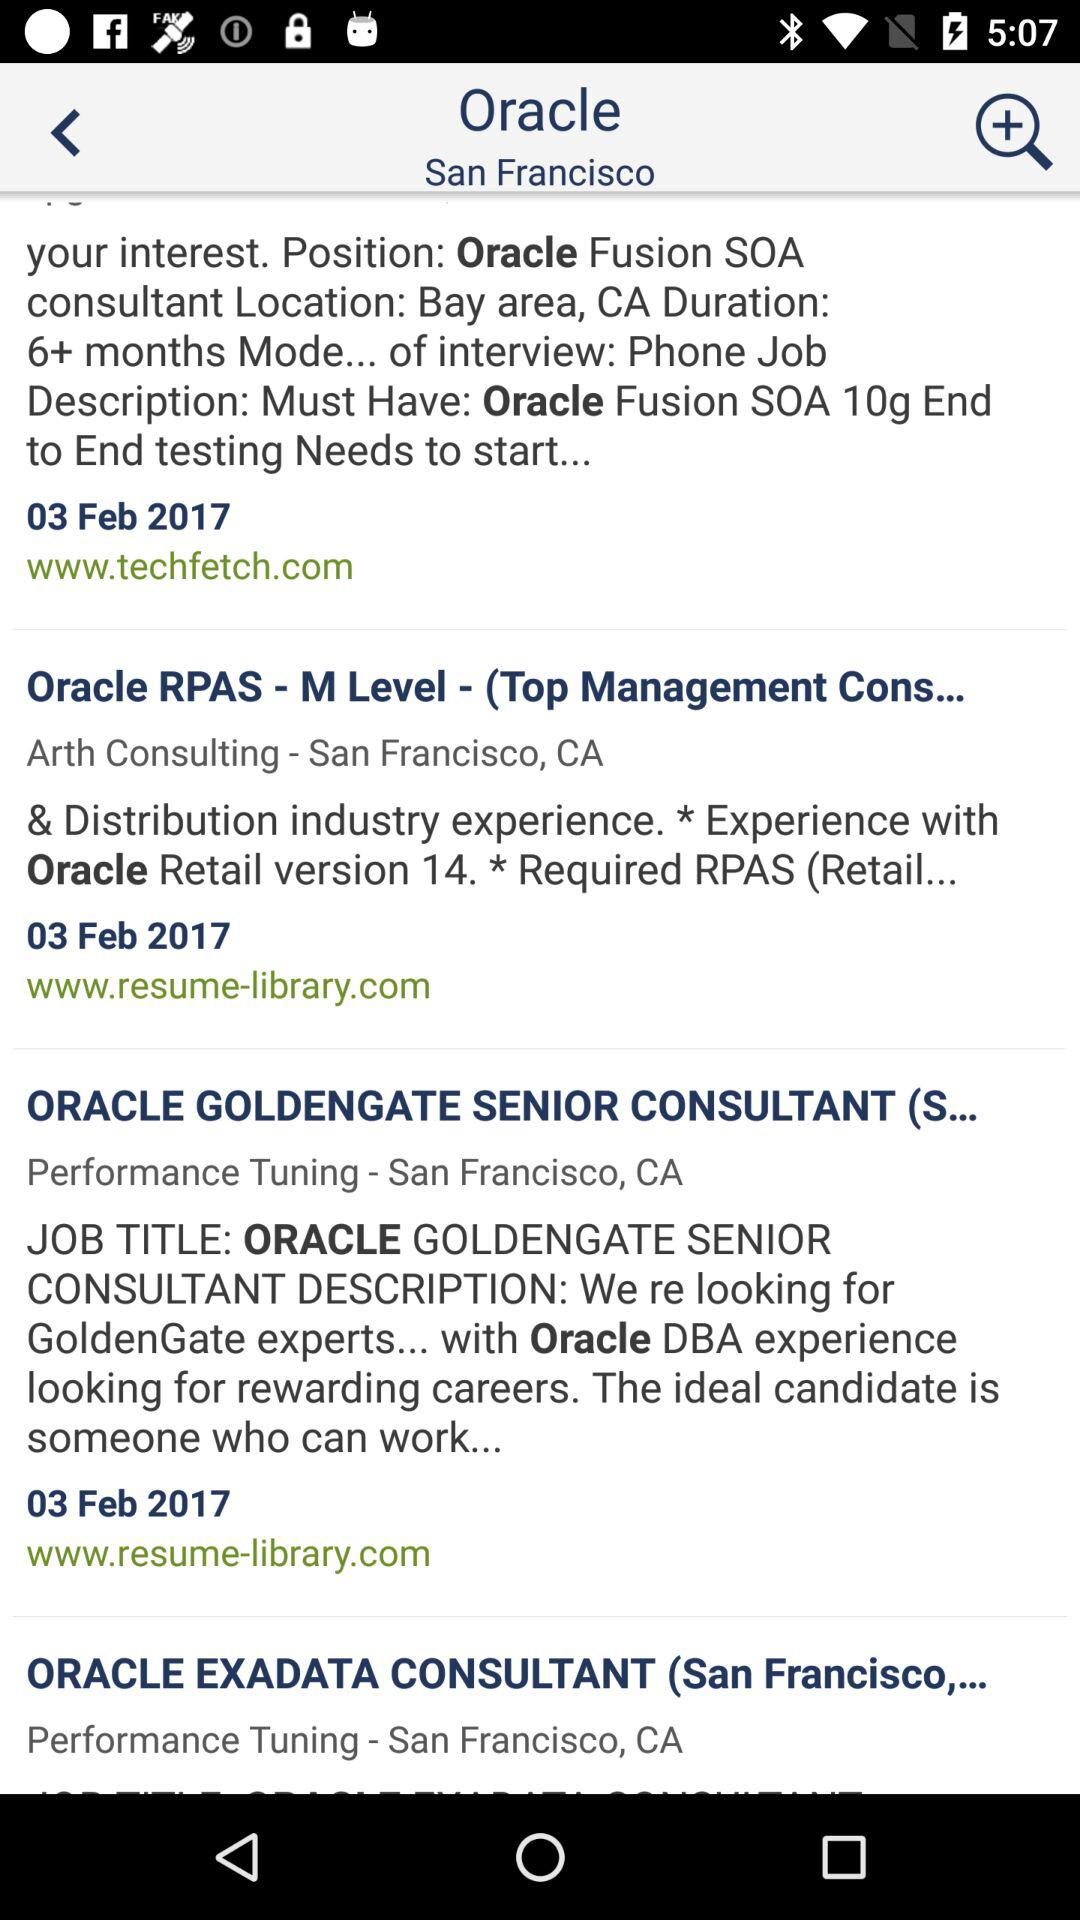What is the level of the "Oracle" RPAS? The level of "Oracle" RPAS is M. 